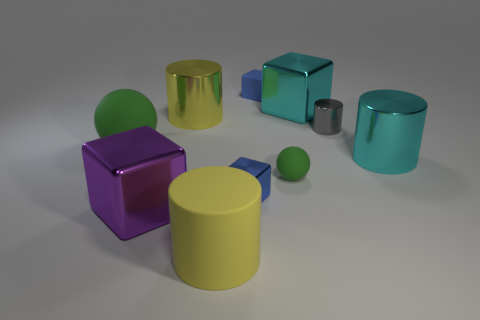What feelings might this arrangement of objects evoke in a viewer? The arrangement of the objects with their various colors and textures can evoke a sense of calm and order. The soft lighting and the simple, clean lines of the shapes provide a minimalist aesthetic. The diversity in the objects' colors could also stir up a playful curiosity, as they might resemble a set of sophisticated and modern toys. Could these objects suggest any specific theme or concept? Certainly, this collection of geometric shapes and contrasting textures could be seen as a representation of diversity and harmony within a system. Each object maintains its individual characteristics while coexisting peacefully with the others, which might suggest a theme of unity in diversity. Alternatively, one could interpret it as an abstract representation of an urban skyline, with varied buildings standing side by side. 